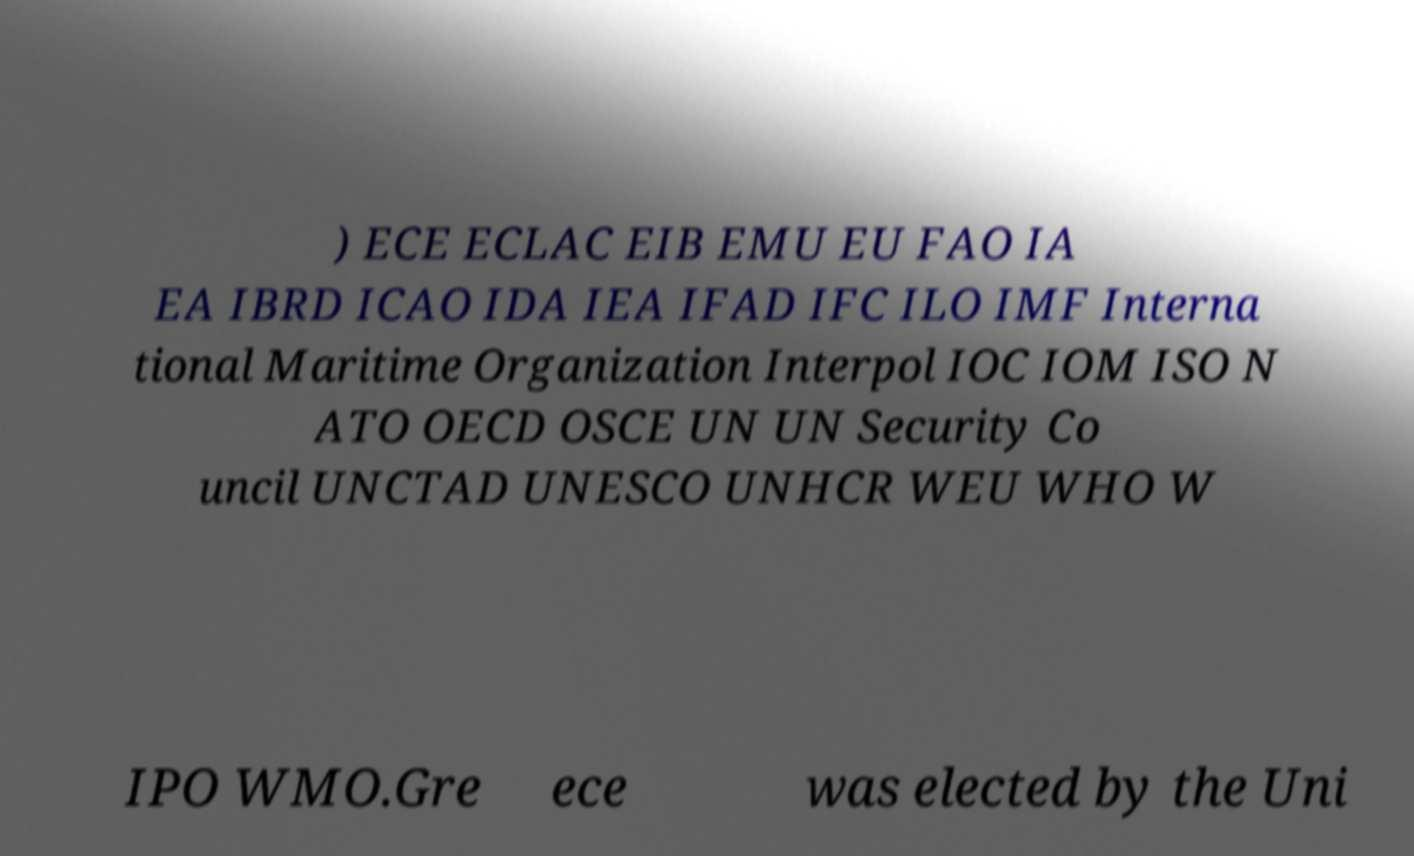Could you extract and type out the text from this image? ) ECE ECLAC EIB EMU EU FAO IA EA IBRD ICAO IDA IEA IFAD IFC ILO IMF Interna tional Maritime Organization Interpol IOC IOM ISO N ATO OECD OSCE UN UN Security Co uncil UNCTAD UNESCO UNHCR WEU WHO W IPO WMO.Gre ece was elected by the Uni 